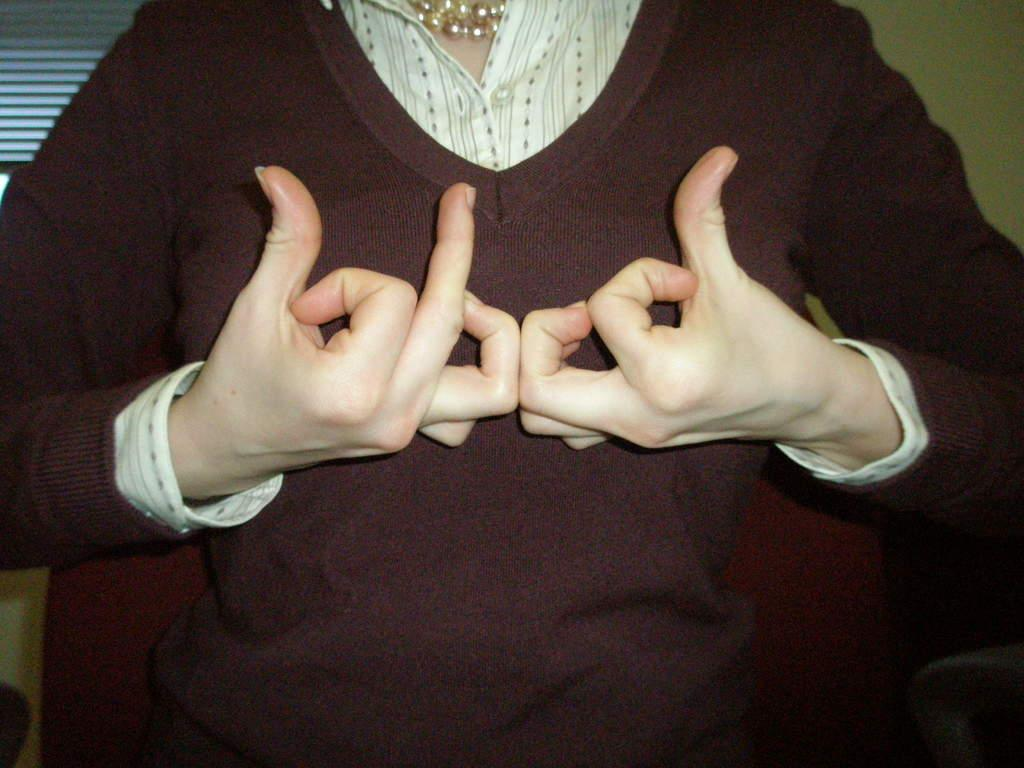What is the main subject of the image? There is a person standing in the image. What is the person doing in the image? The person appears to be using sign language with their fingers. What type of soap is the person holding in the image? There is no soap present in the image; the person is using sign language with their fingers. What rule is the person breaking in the image? There is no indication in the image that the person is breaking any rules. 